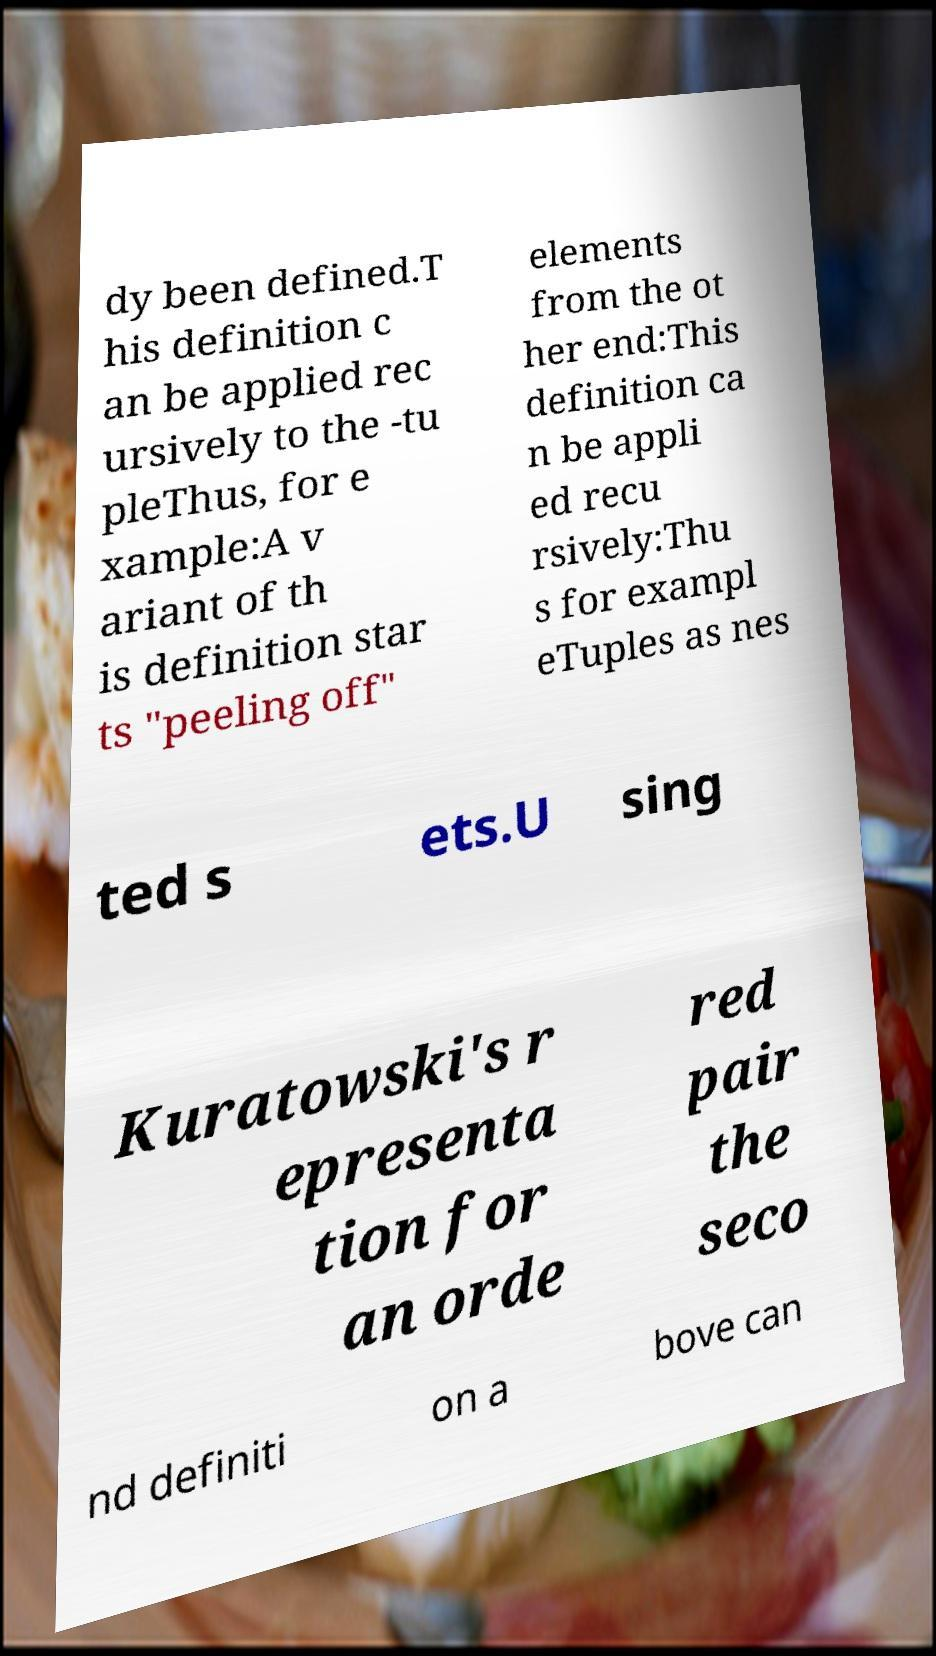Can you accurately transcribe the text from the provided image for me? dy been defined.T his definition c an be applied rec ursively to the -tu pleThus, for e xample:A v ariant of th is definition star ts "peeling off" elements from the ot her end:This definition ca n be appli ed recu rsively:Thu s for exampl eTuples as nes ted s ets.U sing Kuratowski's r epresenta tion for an orde red pair the seco nd definiti on a bove can 